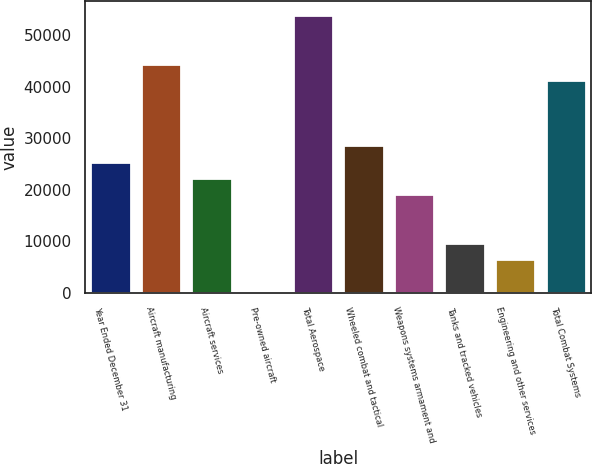Convert chart to OTSL. <chart><loc_0><loc_0><loc_500><loc_500><bar_chart><fcel>Year Ended December 31<fcel>Aircraft manufacturing<fcel>Aircraft services<fcel>Pre-owned aircraft<fcel>Total Aerospace<fcel>Wheeled combat and tactical<fcel>Weapons systems armament and<fcel>Tanks and tracked vehicles<fcel>Engineering and other services<fcel>Total Combat Systems<nl><fcel>25447<fcel>44449<fcel>22280<fcel>111<fcel>53950<fcel>28614<fcel>19113<fcel>9612<fcel>6445<fcel>41282<nl></chart> 